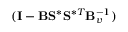<formula> <loc_0><loc_0><loc_500><loc_500>( I - B S ^ { \ast } S ^ { \ast T } B _ { v } ^ { - 1 } )</formula> 